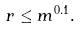Convert formula to latex. <formula><loc_0><loc_0><loc_500><loc_500>r \leq m ^ { 0 . 1 } .</formula> 